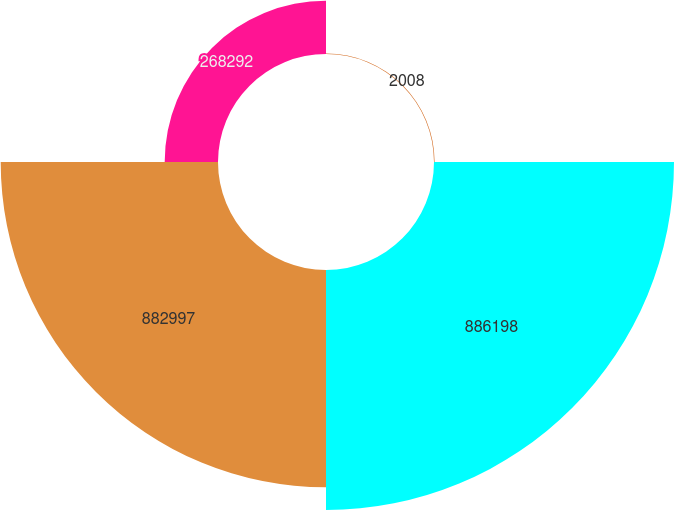<chart> <loc_0><loc_0><loc_500><loc_500><pie_chart><fcel>2008<fcel>886198<fcel>882997<fcel>268292<nl><fcel>0.11%<fcel>46.95%<fcel>42.51%<fcel>10.43%<nl></chart> 